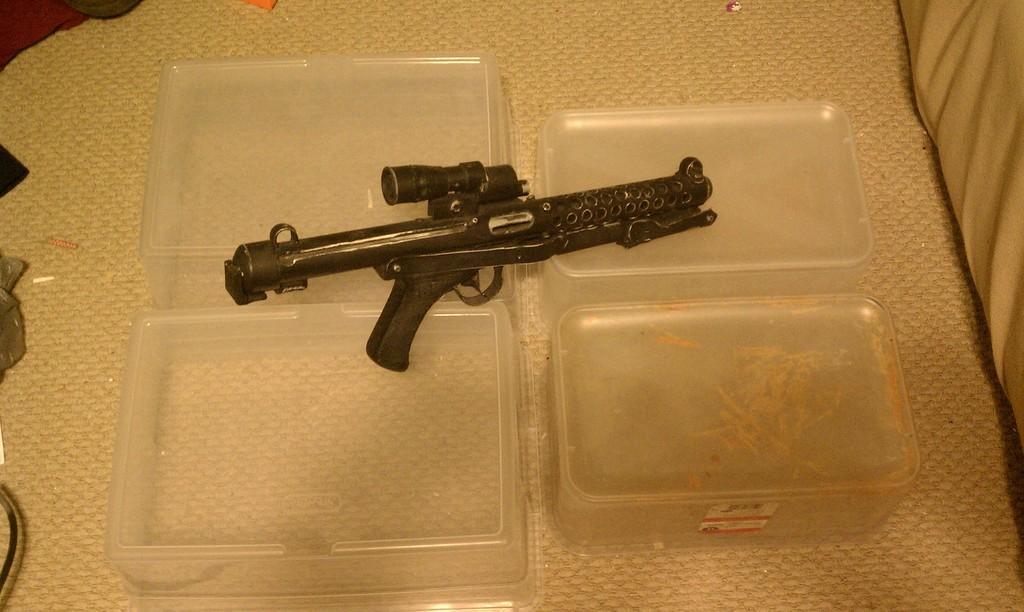Could you give a brief overview of what you see in this image? In this image there is a table, on that table there are boxes, on that boxes there is a gun. 